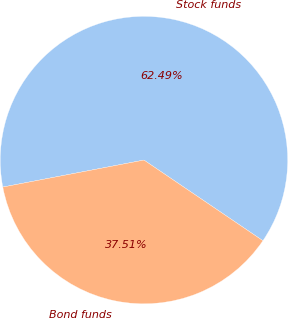Convert chart. <chart><loc_0><loc_0><loc_500><loc_500><pie_chart><fcel>Stock funds<fcel>Bond funds<nl><fcel>62.49%<fcel>37.51%<nl></chart> 